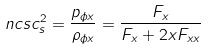<formula> <loc_0><loc_0><loc_500><loc_500>\ n { c s } c _ { s } ^ { 2 } = \frac { p _ { \phi x } } { \rho _ { \phi x } } = \frac { F _ { x } } { F _ { x } + 2 x F _ { x x } }</formula> 